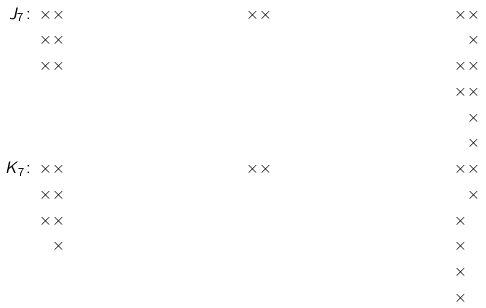<formula> <loc_0><loc_0><loc_500><loc_500>J _ { 7 } \colon \, \times & \times & \times & \times & \times & \times \\ \times & \times & & & & \times \\ \times & \times & & & \times & \times \\ & & & & \times & \times \\ & & & & & \times \\ & & & & & \times \\ \quad K _ { 7 } \colon \, \times & \times & \times & \times & \times & \times \\ \times & \times & & & & \times \\ \times & \times & & & \times & \\ & \times & & & \times & \\ & & & & \times & \\ & & & & \times & \\</formula> 